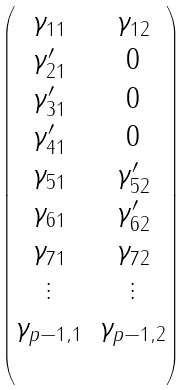<formula> <loc_0><loc_0><loc_500><loc_500>\begin{pmatrix} \gamma _ { 1 1 } & \gamma _ { 1 2 } \\ \gamma _ { 2 1 } ^ { \prime } & 0 \\ \gamma _ { 3 1 } ^ { \prime } & 0 \\ \gamma _ { 4 1 } ^ { \prime } & 0 \\ \gamma _ { 5 1 } & \gamma _ { 5 2 } ^ { \prime } \\ \gamma _ { 6 1 } & \gamma _ { 6 2 } ^ { \prime } \\ \gamma _ { 7 1 } & \gamma _ { 7 2 } \\ \vdots & \vdots \\ \gamma _ { p - 1 , 1 } & \gamma _ { p - 1 , 2 } \\ & \end{pmatrix}</formula> 